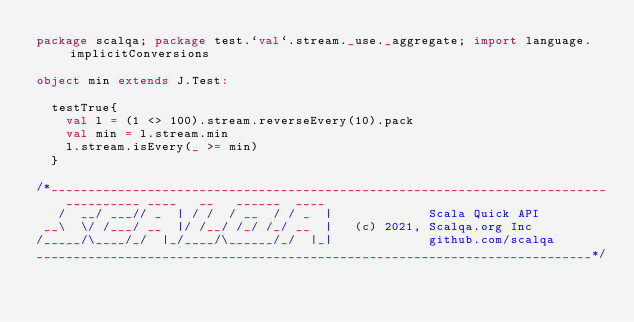Convert code to text. <code><loc_0><loc_0><loc_500><loc_500><_Scala_>package scalqa; package test.`val`.stream._use._aggregate; import language.implicitConversions

object min extends J.Test:

  testTrue{
    val l = (1 <> 100).stream.reverseEvery(10).pack
    val min = l.stream.min
    l.stream.isEvery(_ >= min)
  }

/*___________________________________________________________________________
    __________ ____   __   ______  ____
   /  __/ ___// _  | / /  / __  / / _  |             Scala Quick API
 __\  \/ /___/ __  |/ /__/ /_/ /_/ __  |   (c) 2021, Scalqa.org Inc
/_____/\____/_/  |_/____/\______/_/  |_|             github.com/scalqa
___________________________________________________________________________*/
</code> 